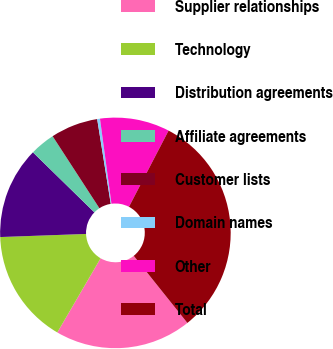Convert chart. <chart><loc_0><loc_0><loc_500><loc_500><pie_chart><fcel>Supplier relationships<fcel>Technology<fcel>Distribution agreements<fcel>Affiliate agreements<fcel>Customer lists<fcel>Domain names<fcel>Other<fcel>Total<nl><fcel>19.14%<fcel>16.02%<fcel>12.89%<fcel>3.52%<fcel>6.64%<fcel>0.39%<fcel>9.77%<fcel>31.64%<nl></chart> 